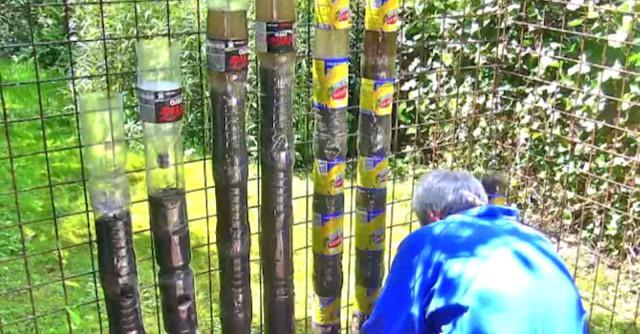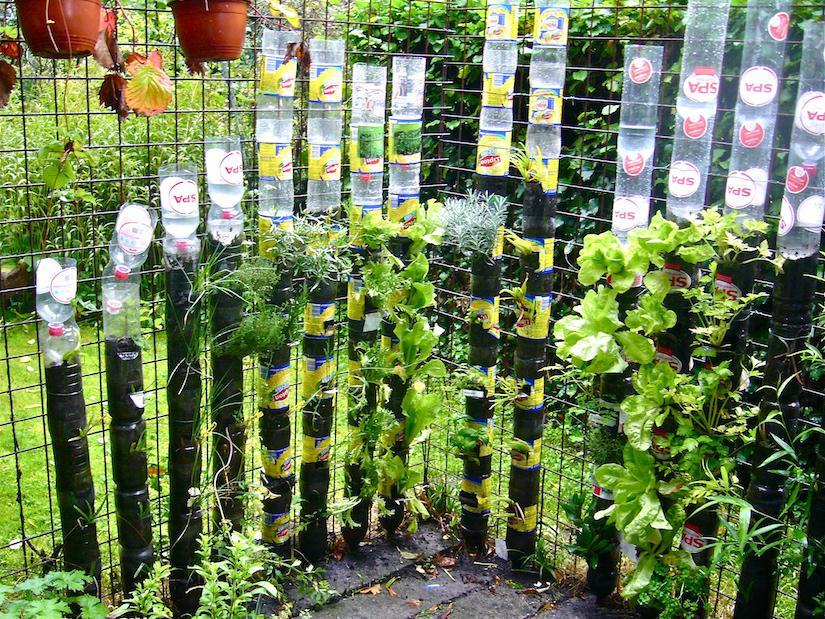The first image is the image on the left, the second image is the image on the right. Assess this claim about the two images: "One image shows a man in a blue shirt standing in front of two hanging orange planters and a row of cylinder shapes topped with up-ended plastic bottles.". Correct or not? Answer yes or no. No. The first image is the image on the left, the second image is the image on the right. Examine the images to the left and right. Is the description "A man in a blue shirt is tending to a garden in the image on the right." accurate? Answer yes or no. No. 